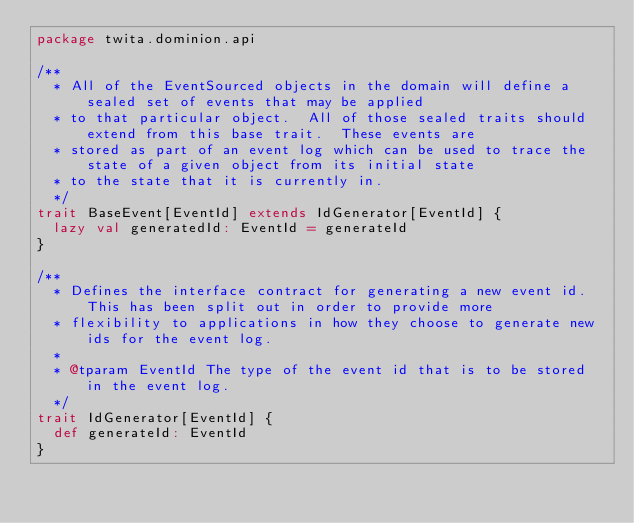<code> <loc_0><loc_0><loc_500><loc_500><_Scala_>package twita.dominion.api

/**
  * All of the EventSourced objects in the domain will define a sealed set of events that may be applied
  * to that particular object.  All of those sealed traits should extend from this base trait.  These events are
  * stored as part of an event log which can be used to trace the state of a given object from its initial state
  * to the state that it is currently in.
  */
trait BaseEvent[EventId] extends IdGenerator[EventId] {
  lazy val generatedId: EventId = generateId
}

/**
  * Defines the interface contract for generating a new event id.  This has been split out in order to provide more
  * flexibility to applications in how they choose to generate new ids for the event log.
  *
  * @tparam EventId The type of the event id that is to be stored in the event log.
  */
trait IdGenerator[EventId] {
  def generateId: EventId
}
</code> 